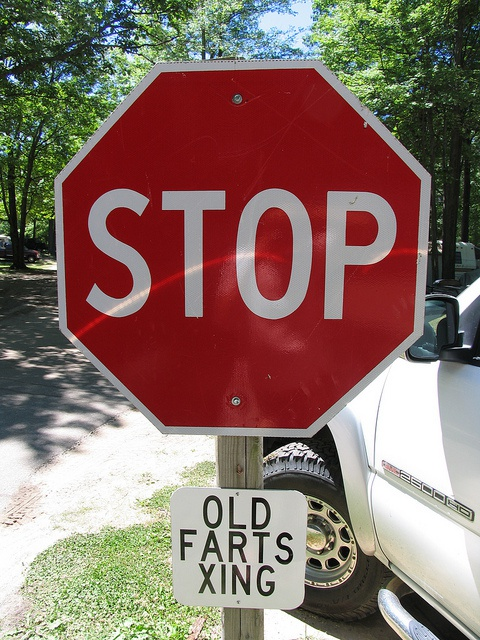Describe the objects in this image and their specific colors. I can see stop sign in black, maroon, darkgray, and brown tones, truck in black, white, darkgray, and gray tones, car in black, white, darkgray, and gray tones, and car in black, gray, and teal tones in this image. 